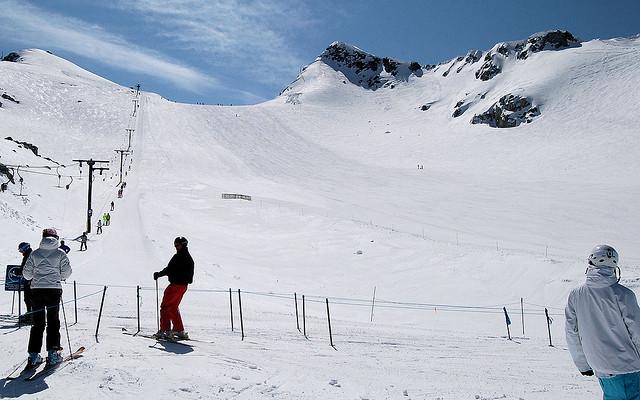Why are people wearing helmets?
Quick response, please. Skiing. What is the name of the sport these people are engaging in?
Write a very short answer. Skiing. Are the people cold?
Be succinct. Yes. 